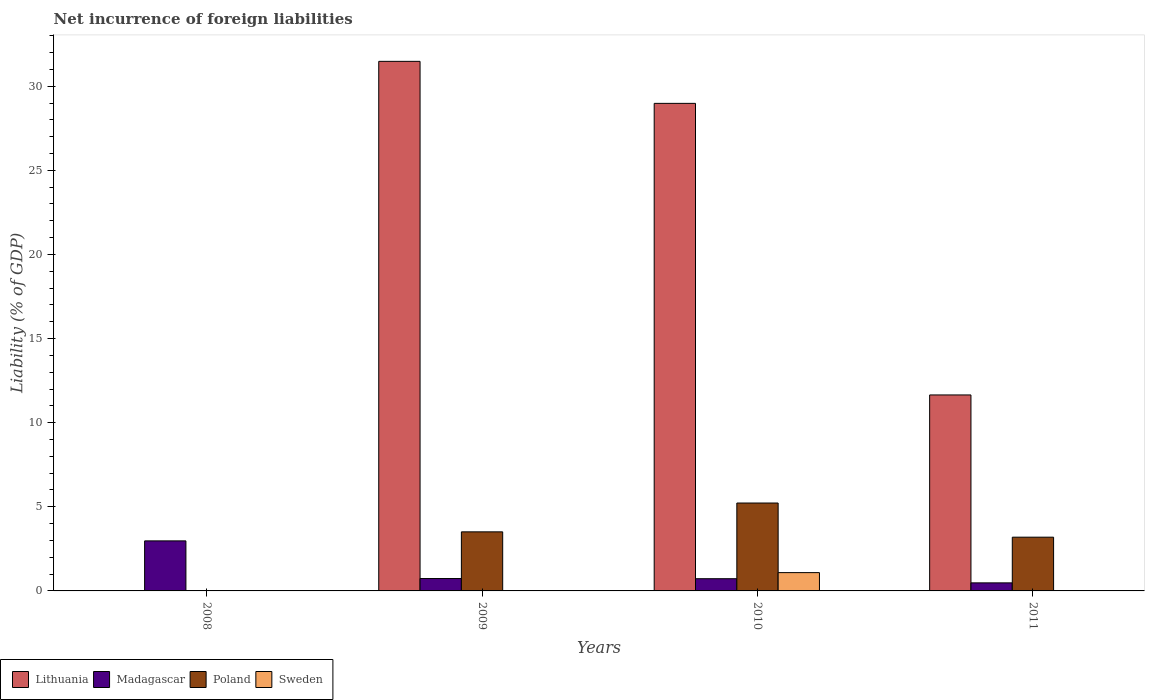How many different coloured bars are there?
Offer a very short reply. 4. Are the number of bars per tick equal to the number of legend labels?
Offer a terse response. No. Are the number of bars on each tick of the X-axis equal?
Keep it short and to the point. No. What is the net incurrence of foreign liabilities in Poland in 2008?
Ensure brevity in your answer.  0. Across all years, what is the maximum net incurrence of foreign liabilities in Madagascar?
Keep it short and to the point. 2.97. What is the total net incurrence of foreign liabilities in Poland in the graph?
Provide a succinct answer. 11.93. What is the difference between the net incurrence of foreign liabilities in Lithuania in 2009 and that in 2010?
Offer a very short reply. 2.5. What is the difference between the net incurrence of foreign liabilities in Sweden in 2011 and the net incurrence of foreign liabilities in Lithuania in 2010?
Give a very brief answer. -28.98. What is the average net incurrence of foreign liabilities in Lithuania per year?
Keep it short and to the point. 18.03. In the year 2009, what is the difference between the net incurrence of foreign liabilities in Poland and net incurrence of foreign liabilities in Madagascar?
Offer a very short reply. 2.77. What is the ratio of the net incurrence of foreign liabilities in Poland in 2009 to that in 2011?
Keep it short and to the point. 1.1. Is the net incurrence of foreign liabilities in Poland in 2009 less than that in 2011?
Provide a short and direct response. No. What is the difference between the highest and the second highest net incurrence of foreign liabilities in Lithuania?
Your answer should be very brief. 2.5. What is the difference between the highest and the lowest net incurrence of foreign liabilities in Madagascar?
Your answer should be very brief. 2.5. In how many years, is the net incurrence of foreign liabilities in Lithuania greater than the average net incurrence of foreign liabilities in Lithuania taken over all years?
Your response must be concise. 2. Is the sum of the net incurrence of foreign liabilities in Madagascar in 2010 and 2011 greater than the maximum net incurrence of foreign liabilities in Lithuania across all years?
Your answer should be compact. No. Are the values on the major ticks of Y-axis written in scientific E-notation?
Provide a short and direct response. No. Does the graph contain any zero values?
Ensure brevity in your answer.  Yes. Does the graph contain grids?
Give a very brief answer. No. Where does the legend appear in the graph?
Your answer should be compact. Bottom left. How are the legend labels stacked?
Provide a succinct answer. Horizontal. What is the title of the graph?
Give a very brief answer. Net incurrence of foreign liabilities. What is the label or title of the Y-axis?
Provide a succinct answer. Liability (% of GDP). What is the Liability (% of GDP) in Lithuania in 2008?
Ensure brevity in your answer.  0. What is the Liability (% of GDP) of Madagascar in 2008?
Your answer should be compact. 2.97. What is the Liability (% of GDP) in Lithuania in 2009?
Provide a succinct answer. 31.48. What is the Liability (% of GDP) of Madagascar in 2009?
Keep it short and to the point. 0.74. What is the Liability (% of GDP) of Poland in 2009?
Your response must be concise. 3.51. What is the Liability (% of GDP) in Lithuania in 2010?
Provide a succinct answer. 28.98. What is the Liability (% of GDP) of Madagascar in 2010?
Keep it short and to the point. 0.73. What is the Liability (% of GDP) in Poland in 2010?
Keep it short and to the point. 5.22. What is the Liability (% of GDP) of Sweden in 2010?
Your answer should be compact. 1.09. What is the Liability (% of GDP) in Lithuania in 2011?
Offer a terse response. 11.65. What is the Liability (% of GDP) in Madagascar in 2011?
Provide a succinct answer. 0.48. What is the Liability (% of GDP) of Poland in 2011?
Your answer should be compact. 3.19. Across all years, what is the maximum Liability (% of GDP) in Lithuania?
Your response must be concise. 31.48. Across all years, what is the maximum Liability (% of GDP) in Madagascar?
Provide a short and direct response. 2.97. Across all years, what is the maximum Liability (% of GDP) in Poland?
Ensure brevity in your answer.  5.22. Across all years, what is the maximum Liability (% of GDP) in Sweden?
Keep it short and to the point. 1.09. Across all years, what is the minimum Liability (% of GDP) of Lithuania?
Give a very brief answer. 0. Across all years, what is the minimum Liability (% of GDP) of Madagascar?
Your answer should be compact. 0.48. Across all years, what is the minimum Liability (% of GDP) in Poland?
Your answer should be very brief. 0. Across all years, what is the minimum Liability (% of GDP) in Sweden?
Your response must be concise. 0. What is the total Liability (% of GDP) in Lithuania in the graph?
Offer a terse response. 72.1. What is the total Liability (% of GDP) of Madagascar in the graph?
Ensure brevity in your answer.  4.91. What is the total Liability (% of GDP) in Poland in the graph?
Give a very brief answer. 11.93. What is the total Liability (% of GDP) of Sweden in the graph?
Your answer should be very brief. 1.09. What is the difference between the Liability (% of GDP) of Madagascar in 2008 and that in 2009?
Provide a succinct answer. 2.24. What is the difference between the Liability (% of GDP) of Madagascar in 2008 and that in 2010?
Offer a very short reply. 2.25. What is the difference between the Liability (% of GDP) of Madagascar in 2008 and that in 2011?
Give a very brief answer. 2.5. What is the difference between the Liability (% of GDP) of Lithuania in 2009 and that in 2010?
Ensure brevity in your answer.  2.5. What is the difference between the Liability (% of GDP) in Madagascar in 2009 and that in 2010?
Keep it short and to the point. 0.01. What is the difference between the Liability (% of GDP) in Poland in 2009 and that in 2010?
Provide a succinct answer. -1.71. What is the difference between the Liability (% of GDP) in Lithuania in 2009 and that in 2011?
Make the answer very short. 19.83. What is the difference between the Liability (% of GDP) in Madagascar in 2009 and that in 2011?
Offer a very short reply. 0.26. What is the difference between the Liability (% of GDP) of Poland in 2009 and that in 2011?
Your answer should be very brief. 0.32. What is the difference between the Liability (% of GDP) of Lithuania in 2010 and that in 2011?
Give a very brief answer. 17.33. What is the difference between the Liability (% of GDP) of Madagascar in 2010 and that in 2011?
Offer a terse response. 0.25. What is the difference between the Liability (% of GDP) of Poland in 2010 and that in 2011?
Give a very brief answer. 2.03. What is the difference between the Liability (% of GDP) in Madagascar in 2008 and the Liability (% of GDP) in Poland in 2009?
Provide a short and direct response. -0.54. What is the difference between the Liability (% of GDP) in Madagascar in 2008 and the Liability (% of GDP) in Poland in 2010?
Keep it short and to the point. -2.25. What is the difference between the Liability (% of GDP) in Madagascar in 2008 and the Liability (% of GDP) in Sweden in 2010?
Offer a very short reply. 1.89. What is the difference between the Liability (% of GDP) in Madagascar in 2008 and the Liability (% of GDP) in Poland in 2011?
Offer a very short reply. -0.22. What is the difference between the Liability (% of GDP) in Lithuania in 2009 and the Liability (% of GDP) in Madagascar in 2010?
Offer a terse response. 30.75. What is the difference between the Liability (% of GDP) in Lithuania in 2009 and the Liability (% of GDP) in Poland in 2010?
Provide a succinct answer. 26.25. What is the difference between the Liability (% of GDP) in Lithuania in 2009 and the Liability (% of GDP) in Sweden in 2010?
Your answer should be very brief. 30.39. What is the difference between the Liability (% of GDP) of Madagascar in 2009 and the Liability (% of GDP) of Poland in 2010?
Make the answer very short. -4.49. What is the difference between the Liability (% of GDP) in Madagascar in 2009 and the Liability (% of GDP) in Sweden in 2010?
Provide a succinct answer. -0.35. What is the difference between the Liability (% of GDP) of Poland in 2009 and the Liability (% of GDP) of Sweden in 2010?
Offer a very short reply. 2.42. What is the difference between the Liability (% of GDP) of Lithuania in 2009 and the Liability (% of GDP) of Madagascar in 2011?
Provide a succinct answer. 31. What is the difference between the Liability (% of GDP) in Lithuania in 2009 and the Liability (% of GDP) in Poland in 2011?
Your answer should be very brief. 28.28. What is the difference between the Liability (% of GDP) of Madagascar in 2009 and the Liability (% of GDP) of Poland in 2011?
Make the answer very short. -2.46. What is the difference between the Liability (% of GDP) in Lithuania in 2010 and the Liability (% of GDP) in Madagascar in 2011?
Your answer should be very brief. 28.5. What is the difference between the Liability (% of GDP) in Lithuania in 2010 and the Liability (% of GDP) in Poland in 2011?
Your answer should be very brief. 25.79. What is the difference between the Liability (% of GDP) of Madagascar in 2010 and the Liability (% of GDP) of Poland in 2011?
Give a very brief answer. -2.47. What is the average Liability (% of GDP) in Lithuania per year?
Your answer should be compact. 18.03. What is the average Liability (% of GDP) of Madagascar per year?
Your answer should be compact. 1.23. What is the average Liability (% of GDP) in Poland per year?
Your answer should be compact. 2.98. What is the average Liability (% of GDP) of Sweden per year?
Provide a succinct answer. 0.27. In the year 2009, what is the difference between the Liability (% of GDP) of Lithuania and Liability (% of GDP) of Madagascar?
Make the answer very short. 30.74. In the year 2009, what is the difference between the Liability (% of GDP) in Lithuania and Liability (% of GDP) in Poland?
Make the answer very short. 27.97. In the year 2009, what is the difference between the Liability (% of GDP) of Madagascar and Liability (% of GDP) of Poland?
Offer a very short reply. -2.77. In the year 2010, what is the difference between the Liability (% of GDP) in Lithuania and Liability (% of GDP) in Madagascar?
Provide a short and direct response. 28.25. In the year 2010, what is the difference between the Liability (% of GDP) of Lithuania and Liability (% of GDP) of Poland?
Offer a terse response. 23.75. In the year 2010, what is the difference between the Liability (% of GDP) of Lithuania and Liability (% of GDP) of Sweden?
Your answer should be very brief. 27.89. In the year 2010, what is the difference between the Liability (% of GDP) of Madagascar and Liability (% of GDP) of Poland?
Provide a short and direct response. -4.5. In the year 2010, what is the difference between the Liability (% of GDP) in Madagascar and Liability (% of GDP) in Sweden?
Your answer should be compact. -0.36. In the year 2010, what is the difference between the Liability (% of GDP) in Poland and Liability (% of GDP) in Sweden?
Provide a succinct answer. 4.14. In the year 2011, what is the difference between the Liability (% of GDP) of Lithuania and Liability (% of GDP) of Madagascar?
Offer a very short reply. 11.17. In the year 2011, what is the difference between the Liability (% of GDP) in Lithuania and Liability (% of GDP) in Poland?
Make the answer very short. 8.45. In the year 2011, what is the difference between the Liability (% of GDP) of Madagascar and Liability (% of GDP) of Poland?
Your response must be concise. -2.72. What is the ratio of the Liability (% of GDP) in Madagascar in 2008 to that in 2009?
Ensure brevity in your answer.  4.04. What is the ratio of the Liability (% of GDP) in Madagascar in 2008 to that in 2010?
Provide a succinct answer. 4.1. What is the ratio of the Liability (% of GDP) in Madagascar in 2008 to that in 2011?
Your answer should be compact. 6.21. What is the ratio of the Liability (% of GDP) of Lithuania in 2009 to that in 2010?
Provide a short and direct response. 1.09. What is the ratio of the Liability (% of GDP) of Poland in 2009 to that in 2010?
Keep it short and to the point. 0.67. What is the ratio of the Liability (% of GDP) of Lithuania in 2009 to that in 2011?
Make the answer very short. 2.7. What is the ratio of the Liability (% of GDP) in Madagascar in 2009 to that in 2011?
Your answer should be compact. 1.54. What is the ratio of the Liability (% of GDP) in Poland in 2009 to that in 2011?
Make the answer very short. 1.1. What is the ratio of the Liability (% of GDP) in Lithuania in 2010 to that in 2011?
Your response must be concise. 2.49. What is the ratio of the Liability (% of GDP) in Madagascar in 2010 to that in 2011?
Offer a terse response. 1.52. What is the ratio of the Liability (% of GDP) in Poland in 2010 to that in 2011?
Offer a very short reply. 1.64. What is the difference between the highest and the second highest Liability (% of GDP) in Lithuania?
Offer a terse response. 2.5. What is the difference between the highest and the second highest Liability (% of GDP) of Madagascar?
Offer a very short reply. 2.24. What is the difference between the highest and the second highest Liability (% of GDP) in Poland?
Offer a terse response. 1.71. What is the difference between the highest and the lowest Liability (% of GDP) in Lithuania?
Offer a very short reply. 31.48. What is the difference between the highest and the lowest Liability (% of GDP) of Madagascar?
Make the answer very short. 2.5. What is the difference between the highest and the lowest Liability (% of GDP) in Poland?
Provide a succinct answer. 5.22. What is the difference between the highest and the lowest Liability (% of GDP) in Sweden?
Keep it short and to the point. 1.09. 